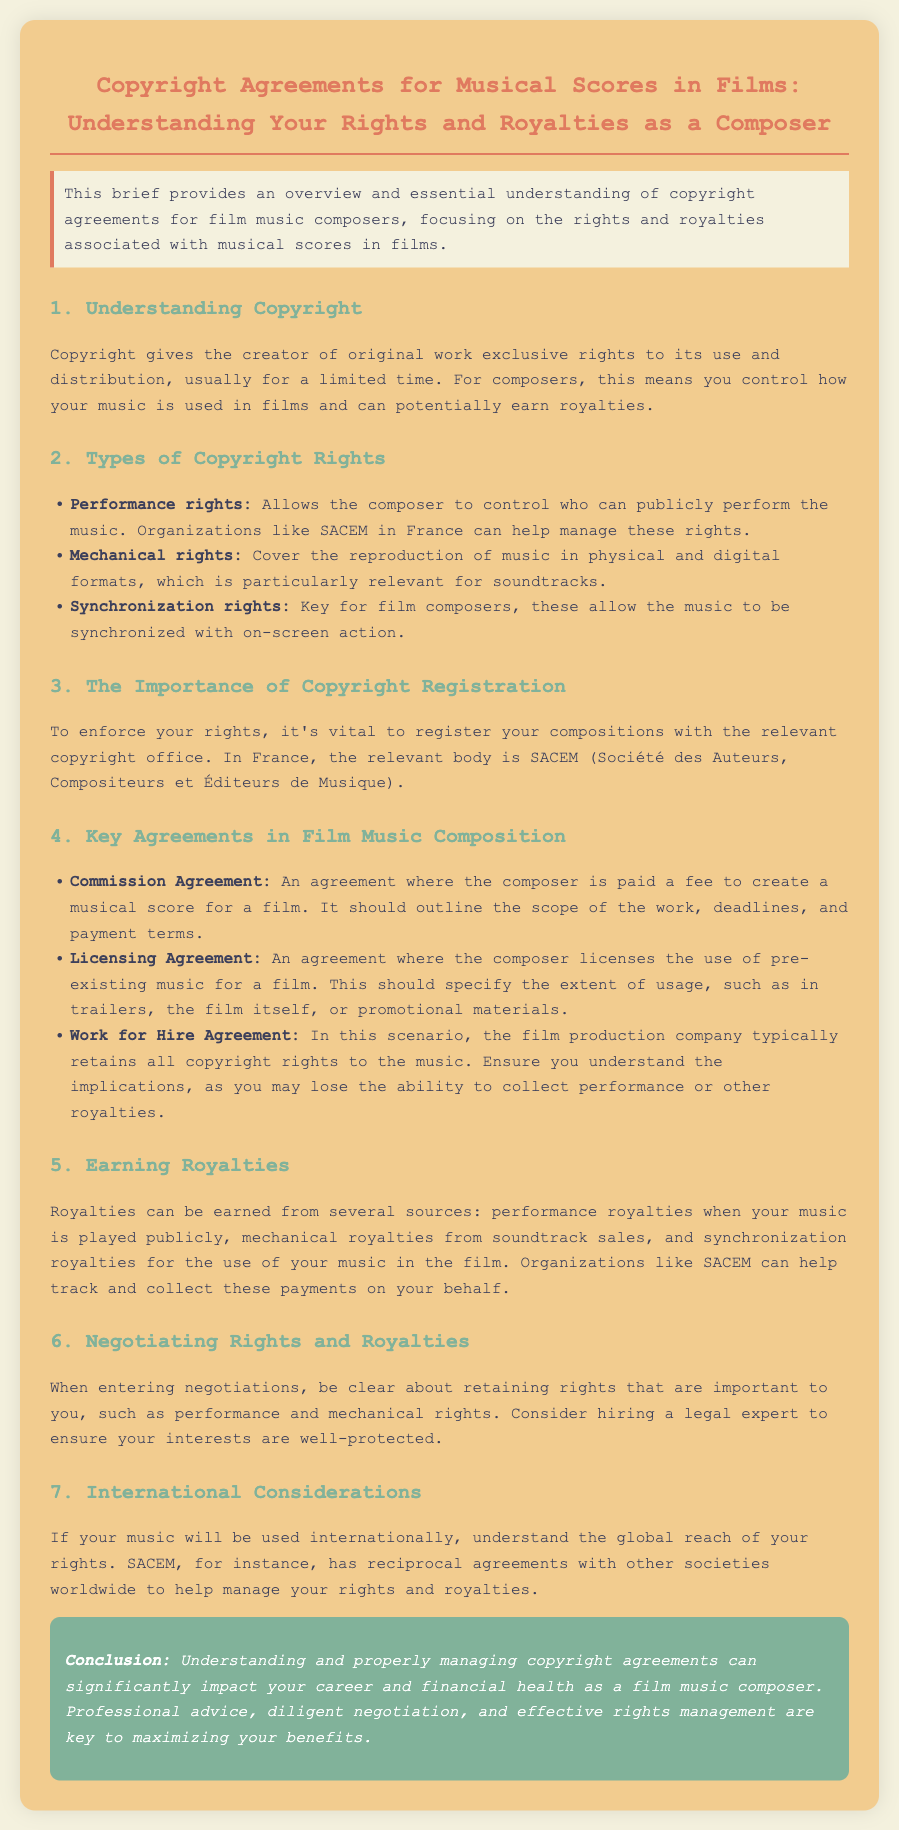what is the main focus of the brief? The brief provides an overview and essential understanding of copyright agreements for film music composers.
Answer: copyright agreements for film music composers who can help manage performance rights in France? Organizations like SACEM in France can help manage performance rights.
Answer: SACEM what type of agreement typically allows the film production company to retain all copyright rights? In this scenario, the film production company typically retains all copyright rights to the music.
Answer: Work for Hire Agreement how can composers earn royalties? Composers can earn royalties from several sources such as performance royalties, mechanical royalties, and synchronization royalties.
Answer: performance royalties, mechanical royalties, synchronization royalties why is it important to register compositions? To enforce your rights, it's vital to register your compositions with the relevant copyright office.
Answer: enforce your rights what is a Commission Agreement? An agreement where the composer is paid a fee to create a musical score for a film.
Answer: Commission Agreement what should a Licensing Agreement specify? A Licensing Agreement should specify the extent of usage, such as in trailers, the film itself, or promotional materials.
Answer: extent of usage which organization can help track and collect royalty payments? Organizations like SACEM can help track and collect these payments on your behalf.
Answer: SACEM what is crucial when entering negotiations? Be clear about retaining rights that are important to you, such as performance and mechanical rights.
Answer: retaining rights 